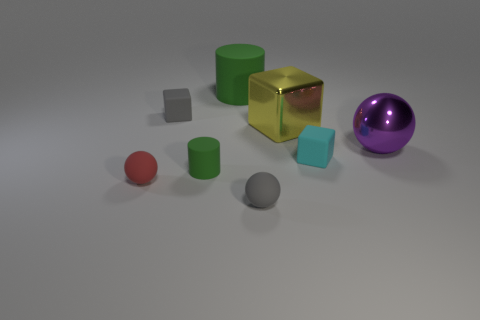How many other things are there of the same color as the small rubber cylinder?
Your answer should be very brief. 1. Are there any blue rubber cubes that have the same size as the yellow metal cube?
Ensure brevity in your answer.  No. Does the cylinder in front of the yellow metal thing have the same color as the big matte cylinder?
Provide a succinct answer. Yes. What number of blue things are either tiny objects or tiny balls?
Give a very brief answer. 0. How many large rubber things have the same color as the metallic ball?
Provide a short and direct response. 0. Do the small cylinder and the large green thing have the same material?
Your answer should be compact. Yes. There is a small thing behind the big metal sphere; what number of small green rubber objects are in front of it?
Offer a terse response. 1. Is the size of the purple sphere the same as the yellow block?
Provide a short and direct response. Yes. How many green cylinders have the same material as the small gray cube?
Keep it short and to the point. 2. What is the size of the other green rubber thing that is the same shape as the tiny green object?
Keep it short and to the point. Large. 